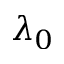Convert formula to latex. <formula><loc_0><loc_0><loc_500><loc_500>\lambda _ { 0 }</formula> 